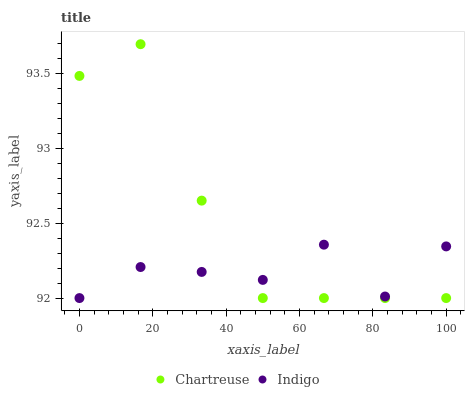Does Indigo have the minimum area under the curve?
Answer yes or no. Yes. Does Chartreuse have the maximum area under the curve?
Answer yes or no. Yes. Does Indigo have the maximum area under the curve?
Answer yes or no. No. Is Indigo the smoothest?
Answer yes or no. Yes. Is Chartreuse the roughest?
Answer yes or no. Yes. Is Indigo the roughest?
Answer yes or no. No. Does Chartreuse have the lowest value?
Answer yes or no. Yes. Does Chartreuse have the highest value?
Answer yes or no. Yes. Does Indigo have the highest value?
Answer yes or no. No. Does Indigo intersect Chartreuse?
Answer yes or no. Yes. Is Indigo less than Chartreuse?
Answer yes or no. No. Is Indigo greater than Chartreuse?
Answer yes or no. No. 